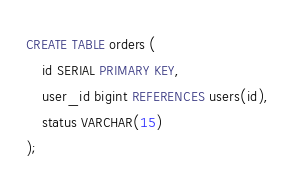<code> <loc_0><loc_0><loc_500><loc_500><_SQL_>CREATE TABLE orders (
    id SERIAL PRIMARY KEY,
    user_id bigint REFERENCES users(id),
    status VARCHAR(15)
);</code> 